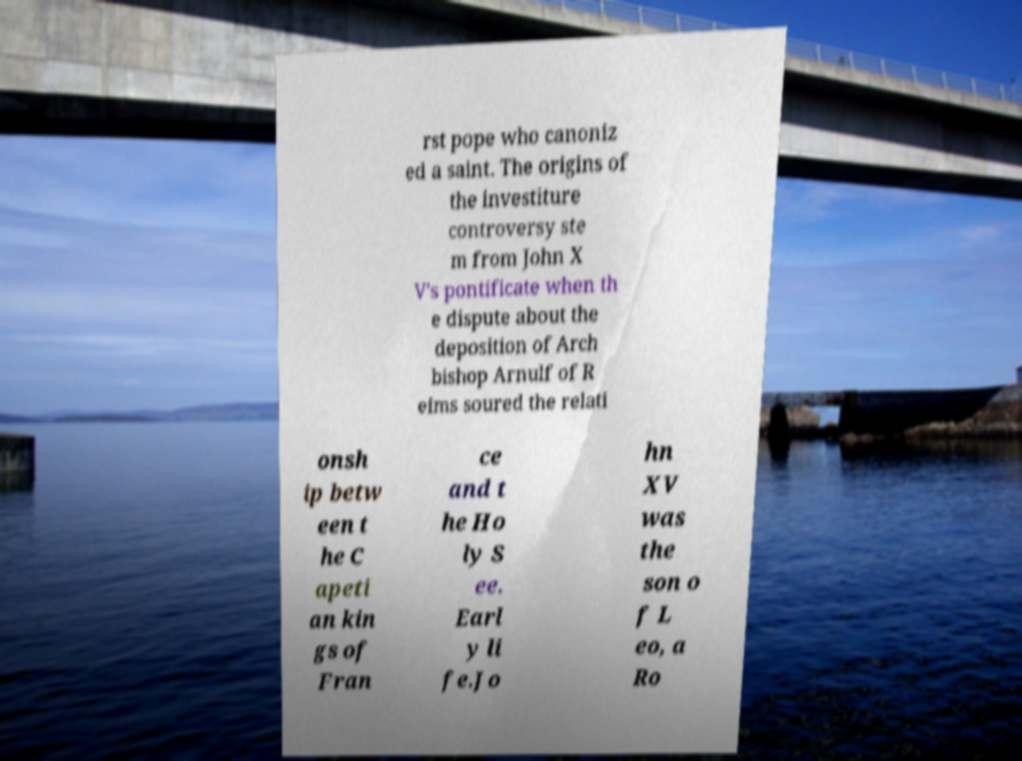I need the written content from this picture converted into text. Can you do that? rst pope who canoniz ed a saint. The origins of the investiture controversy ste m from John X V's pontificate when th e dispute about the deposition of Arch bishop Arnulf of R eims soured the relati onsh ip betw een t he C apeti an kin gs of Fran ce and t he Ho ly S ee. Earl y li fe.Jo hn XV was the son o f L eo, a Ro 